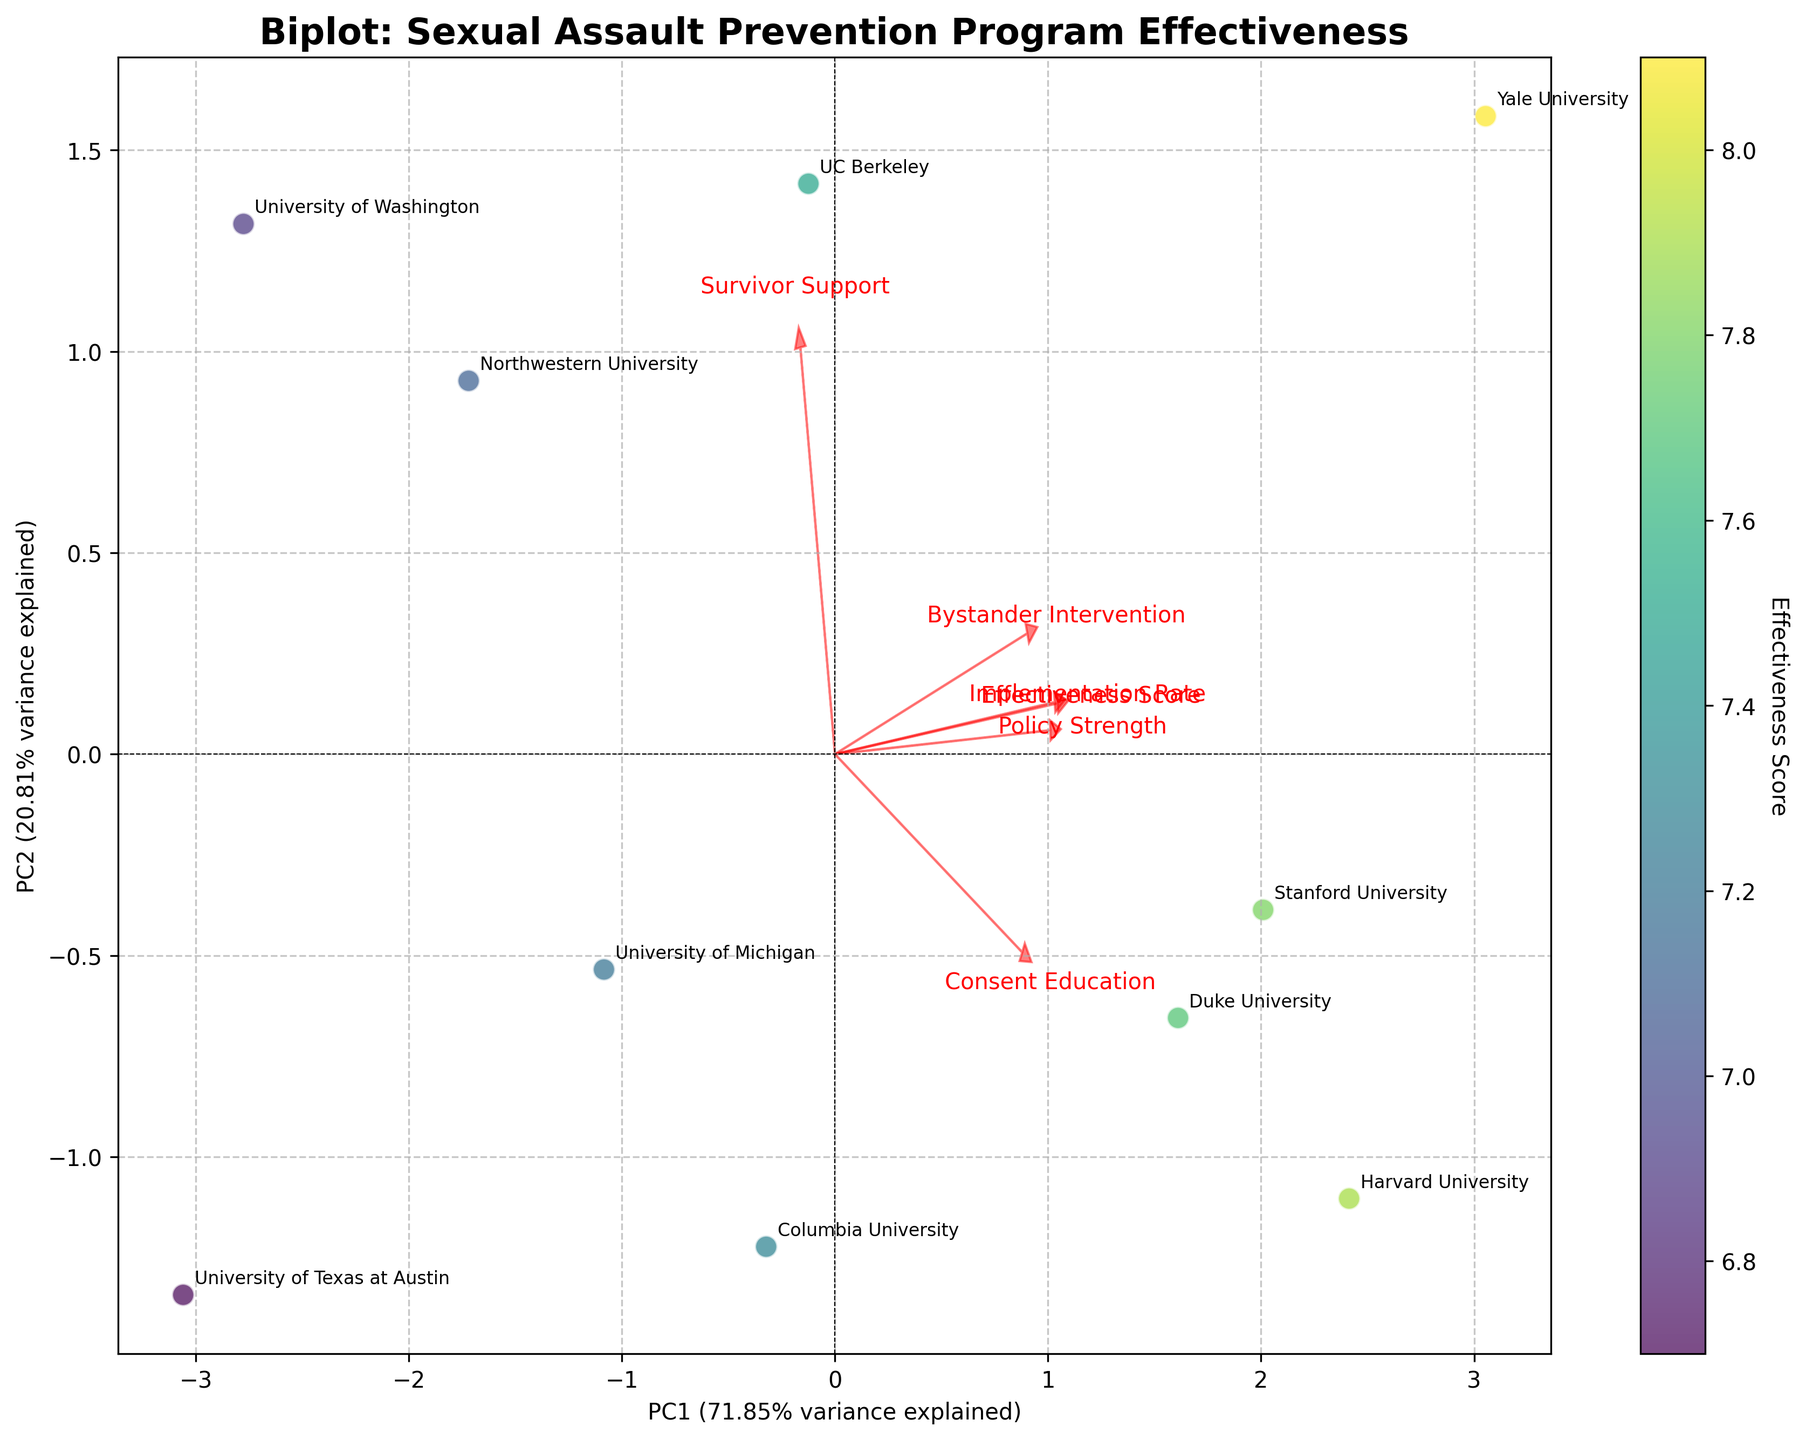What is the title of the biplot? The title is usually located at the top of the figure. From the provided data, the title should indicate what the biplot is about.
Answer: Biplot: Sexual Assault Prevention Program Effectiveness How many universities are represented in the biplot? Each university is represented by a data point which is labeled. Counting the labels gives the number of universities. From the dataset, we see ten universities.
Answer: 10 Which university has the highest effectiveness score? By looking at the colorbar and finding the data point with the darkest color, which indicates the highest effectiveness score. We see that Yale University has the darkest color.
Answer: Yale University Which feature has the longest vector in the biplot? The length of the vector represents the importance or variance explained by that feature. The longest vector is the one which extends furthest from the origin.
Answer: Implementation Rate How are 'Bystander Intervention' and 'Consent Education' related in the biplot? Look at the directions of the vectors for 'Bystander Intervention' and 'Consent Education'. If they point in similar directions or are close to each other, they are positively correlated. In the biplot, these vectors are quite close, indicating a positive relationship.
Answer: Positively correlated Which university clusters most closely with Harvard University? Look for the data point representing Harvard University, then find the nearest labeled data point to it.
Answer: Duke University What is the cumulative variance explained by the first two principal components? This is typically displayed on the x and y axes labels as percentages. Adding these percentages gives the cumulative variance explained. From the code, we estimate: PC1 variance + PC2 variance.
Answer: Approximately 100% Consider 'Policy Strength' and 'Survivor Support'. Which has a more significant influence on PC1? Identify the vectors for 'Policy Strength' and 'Survivor Support' and compare their projections on the x-axis (PC1). The vector extending further along the x-axis has a stronger influence on PC1.
Answer: Policy Strength 